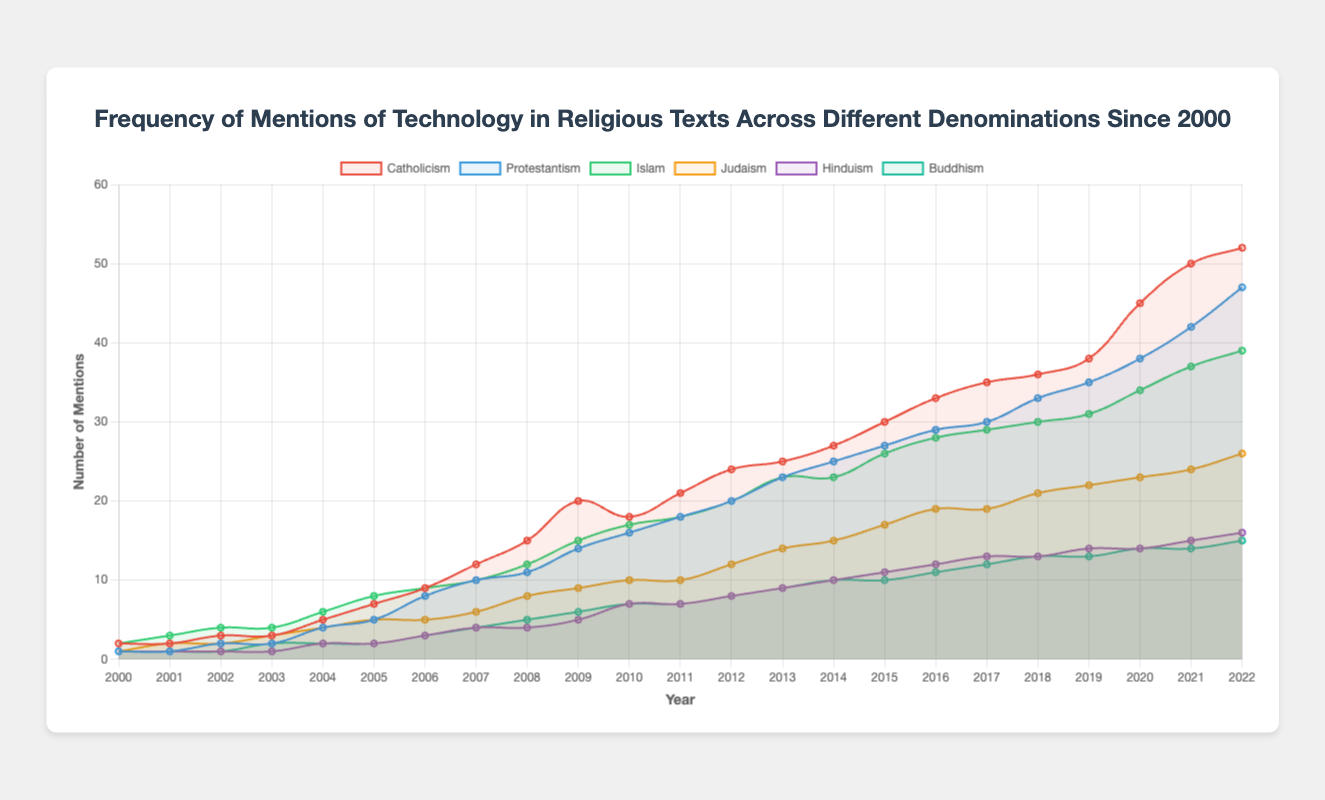What is the denomination with the highest mentions of technology in 2022? The data shows the number of mentions for each denomination in 2022. By visually comparing the values for 2022, we see that Catholicism has the highest mentions.
Answer: Catholicism How does the frequency of mentions of technology compare between Protestantism and Islam in 2015? For 2015, Protestantism has 27 mentions and Islam has 26 mentions. By comparing 27 and 26, we see that Protestantism has more mentions.
Answer: Protestantism What is the average number of mentions of technology in religious texts for Judaism over the period 2010 to 2020? To find the average, sum the mentions from 2010 to 2020 (10 + 10 + 12 + 14 + 15 + 17 + 19 + 19 + 21 + 22 + 23) which equals 182, then divide by the number of years (11). 182/11 = 16.55.
Answer: 16.55 By how much did the mentions of technology in Buddhism increase from 2010 to 2022? Buddhism had 7 mentions in 2010 and 15 mentions in 2022. The increase is 15 - 7, which is 8.
Answer: 8 Which denomination had the least mentions of technology in 2005 and by how much was it less than the denomination with the most mentions that year? In 2005, Hinduism and Buddhism both had 2 mentions, which are the least. Catholicism had the most mentions with 7. The difference is 7 - 2, which is 5.
Answer: Hinduism and Buddhism, 5 What is the trend of technology mentions in Catholicism from 2000 to 2022? By observing the line for Catholicism, it shows a generally increasing trend from 2 mentions in 2000 to 52 mentions in 2022, with a slight dip around 2009-2010.
Answer: Increasing Which year did Protestantism surpass Islam in mentions of technology, and what were the mentions for each denomination that year? From the plot, Protestantism surpassed Islam between 2018 and 2019. In 2019, Protestantism had 35 mentions while Islam had 31 mentions.
Answer: 2019, Protestantism: 35, Islam: 31 What is the sum of all mentions of technology in Hinduism and Buddhism in 2020? For 2020, Hinduism had 14 mentions and Buddhism had 14 mentions. The sum is 14 + 14, which is 28.
Answer: 28 